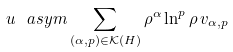Convert formula to latex. <formula><loc_0><loc_0><loc_500><loc_500>u \ a s y m \sum _ { ( \alpha , p ) \in { \mathcal { K } } ( H ) } \rho ^ { \alpha } \ln ^ { p } \rho \, v _ { \alpha , p }</formula> 